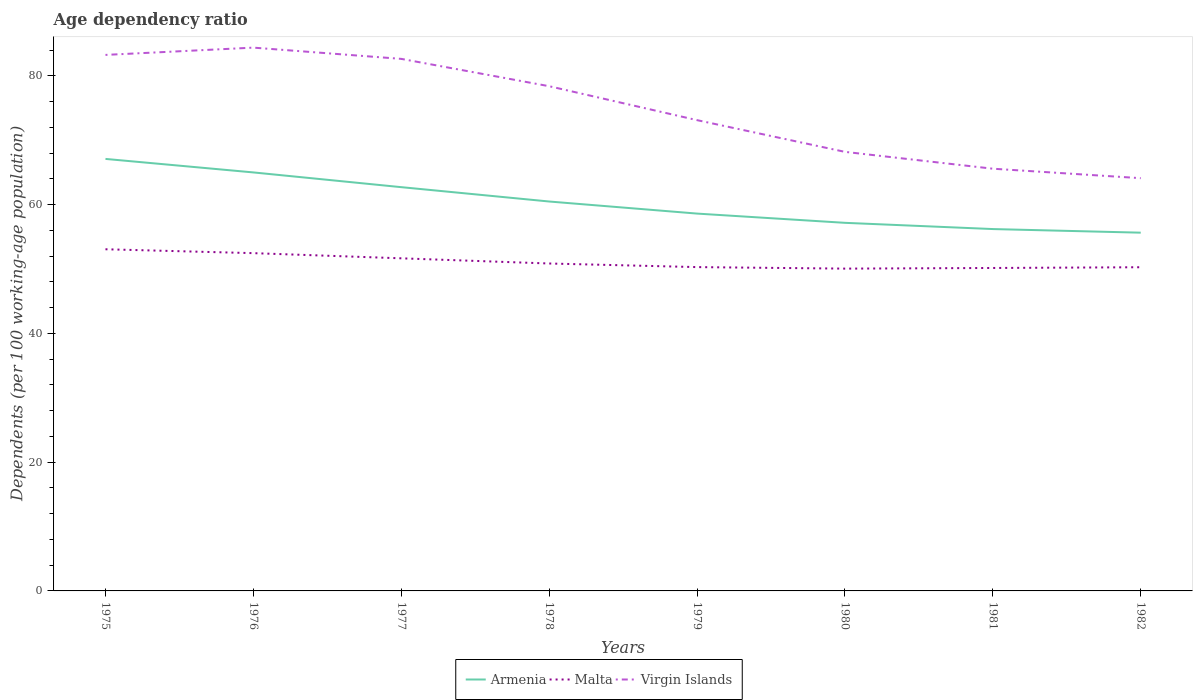How many different coloured lines are there?
Provide a succinct answer. 3. Across all years, what is the maximum age dependency ratio in in Armenia?
Make the answer very short. 55.64. What is the total age dependency ratio in in Malta in the graph?
Keep it short and to the point. 2.3. What is the difference between the highest and the second highest age dependency ratio in in Malta?
Ensure brevity in your answer.  3.01. How many lines are there?
Give a very brief answer. 3. How many years are there in the graph?
Provide a short and direct response. 8. What is the difference between two consecutive major ticks on the Y-axis?
Your answer should be very brief. 20. Does the graph contain any zero values?
Your answer should be very brief. No. Does the graph contain grids?
Give a very brief answer. No. What is the title of the graph?
Give a very brief answer. Age dependency ratio. What is the label or title of the X-axis?
Offer a very short reply. Years. What is the label or title of the Y-axis?
Offer a very short reply. Dependents (per 100 working-age population). What is the Dependents (per 100 working-age population) in Armenia in 1975?
Offer a terse response. 67.09. What is the Dependents (per 100 working-age population) of Malta in 1975?
Offer a terse response. 53.06. What is the Dependents (per 100 working-age population) of Virgin Islands in 1975?
Provide a short and direct response. 83.24. What is the Dependents (per 100 working-age population) of Armenia in 1976?
Ensure brevity in your answer.  64.99. What is the Dependents (per 100 working-age population) of Malta in 1976?
Your answer should be very brief. 52.46. What is the Dependents (per 100 working-age population) in Virgin Islands in 1976?
Provide a succinct answer. 84.37. What is the Dependents (per 100 working-age population) of Armenia in 1977?
Your answer should be very brief. 62.7. What is the Dependents (per 100 working-age population) in Malta in 1977?
Make the answer very short. 51.65. What is the Dependents (per 100 working-age population) of Virgin Islands in 1977?
Ensure brevity in your answer.  82.63. What is the Dependents (per 100 working-age population) in Armenia in 1978?
Your answer should be very brief. 60.48. What is the Dependents (per 100 working-age population) of Malta in 1978?
Your response must be concise. 50.85. What is the Dependents (per 100 working-age population) in Virgin Islands in 1978?
Your response must be concise. 78.38. What is the Dependents (per 100 working-age population) of Armenia in 1979?
Provide a short and direct response. 58.6. What is the Dependents (per 100 working-age population) in Malta in 1979?
Keep it short and to the point. 50.29. What is the Dependents (per 100 working-age population) of Virgin Islands in 1979?
Offer a very short reply. 73.11. What is the Dependents (per 100 working-age population) of Armenia in 1980?
Provide a short and direct response. 57.17. What is the Dependents (per 100 working-age population) of Malta in 1980?
Offer a very short reply. 50.05. What is the Dependents (per 100 working-age population) in Virgin Islands in 1980?
Your answer should be compact. 68.19. What is the Dependents (per 100 working-age population) of Armenia in 1981?
Offer a terse response. 56.2. What is the Dependents (per 100 working-age population) in Malta in 1981?
Keep it short and to the point. 50.15. What is the Dependents (per 100 working-age population) in Virgin Islands in 1981?
Your answer should be very brief. 65.57. What is the Dependents (per 100 working-age population) of Armenia in 1982?
Your response must be concise. 55.64. What is the Dependents (per 100 working-age population) of Malta in 1982?
Offer a very short reply. 50.27. What is the Dependents (per 100 working-age population) of Virgin Islands in 1982?
Offer a very short reply. 64.1. Across all years, what is the maximum Dependents (per 100 working-age population) of Armenia?
Offer a terse response. 67.09. Across all years, what is the maximum Dependents (per 100 working-age population) in Malta?
Keep it short and to the point. 53.06. Across all years, what is the maximum Dependents (per 100 working-age population) of Virgin Islands?
Your answer should be compact. 84.37. Across all years, what is the minimum Dependents (per 100 working-age population) of Armenia?
Ensure brevity in your answer.  55.64. Across all years, what is the minimum Dependents (per 100 working-age population) of Malta?
Make the answer very short. 50.05. Across all years, what is the minimum Dependents (per 100 working-age population) of Virgin Islands?
Your response must be concise. 64.1. What is the total Dependents (per 100 working-age population) in Armenia in the graph?
Provide a short and direct response. 482.87. What is the total Dependents (per 100 working-age population) in Malta in the graph?
Offer a very short reply. 408.78. What is the total Dependents (per 100 working-age population) of Virgin Islands in the graph?
Provide a short and direct response. 599.59. What is the difference between the Dependents (per 100 working-age population) in Armenia in 1975 and that in 1976?
Ensure brevity in your answer.  2.1. What is the difference between the Dependents (per 100 working-age population) in Malta in 1975 and that in 1976?
Give a very brief answer. 0.6. What is the difference between the Dependents (per 100 working-age population) in Virgin Islands in 1975 and that in 1976?
Keep it short and to the point. -1.13. What is the difference between the Dependents (per 100 working-age population) in Armenia in 1975 and that in 1977?
Keep it short and to the point. 4.39. What is the difference between the Dependents (per 100 working-age population) in Malta in 1975 and that in 1977?
Offer a terse response. 1.41. What is the difference between the Dependents (per 100 working-age population) in Virgin Islands in 1975 and that in 1977?
Ensure brevity in your answer.  0.62. What is the difference between the Dependents (per 100 working-age population) of Armenia in 1975 and that in 1978?
Make the answer very short. 6.62. What is the difference between the Dependents (per 100 working-age population) in Malta in 1975 and that in 1978?
Keep it short and to the point. 2.21. What is the difference between the Dependents (per 100 working-age population) in Virgin Islands in 1975 and that in 1978?
Ensure brevity in your answer.  4.86. What is the difference between the Dependents (per 100 working-age population) of Armenia in 1975 and that in 1979?
Make the answer very short. 8.49. What is the difference between the Dependents (per 100 working-age population) of Malta in 1975 and that in 1979?
Provide a short and direct response. 2.77. What is the difference between the Dependents (per 100 working-age population) of Virgin Islands in 1975 and that in 1979?
Provide a short and direct response. 10.13. What is the difference between the Dependents (per 100 working-age population) of Armenia in 1975 and that in 1980?
Offer a very short reply. 9.93. What is the difference between the Dependents (per 100 working-age population) of Malta in 1975 and that in 1980?
Keep it short and to the point. 3.01. What is the difference between the Dependents (per 100 working-age population) in Virgin Islands in 1975 and that in 1980?
Offer a terse response. 15.06. What is the difference between the Dependents (per 100 working-age population) of Armenia in 1975 and that in 1981?
Provide a short and direct response. 10.89. What is the difference between the Dependents (per 100 working-age population) of Malta in 1975 and that in 1981?
Provide a succinct answer. 2.91. What is the difference between the Dependents (per 100 working-age population) in Virgin Islands in 1975 and that in 1981?
Give a very brief answer. 17.67. What is the difference between the Dependents (per 100 working-age population) of Armenia in 1975 and that in 1982?
Make the answer very short. 11.46. What is the difference between the Dependents (per 100 working-age population) in Malta in 1975 and that in 1982?
Provide a short and direct response. 2.79. What is the difference between the Dependents (per 100 working-age population) in Virgin Islands in 1975 and that in 1982?
Make the answer very short. 19.14. What is the difference between the Dependents (per 100 working-age population) of Armenia in 1976 and that in 1977?
Provide a succinct answer. 2.29. What is the difference between the Dependents (per 100 working-age population) in Malta in 1976 and that in 1977?
Your response must be concise. 0.8. What is the difference between the Dependents (per 100 working-age population) in Virgin Islands in 1976 and that in 1977?
Make the answer very short. 1.75. What is the difference between the Dependents (per 100 working-age population) in Armenia in 1976 and that in 1978?
Provide a succinct answer. 4.52. What is the difference between the Dependents (per 100 working-age population) in Malta in 1976 and that in 1978?
Offer a terse response. 1.61. What is the difference between the Dependents (per 100 working-age population) in Virgin Islands in 1976 and that in 1978?
Give a very brief answer. 5.99. What is the difference between the Dependents (per 100 working-age population) of Armenia in 1976 and that in 1979?
Your response must be concise. 6.39. What is the difference between the Dependents (per 100 working-age population) of Malta in 1976 and that in 1979?
Keep it short and to the point. 2.17. What is the difference between the Dependents (per 100 working-age population) of Virgin Islands in 1976 and that in 1979?
Make the answer very short. 11.26. What is the difference between the Dependents (per 100 working-age population) in Armenia in 1976 and that in 1980?
Offer a terse response. 7.83. What is the difference between the Dependents (per 100 working-age population) in Malta in 1976 and that in 1980?
Your answer should be compact. 2.4. What is the difference between the Dependents (per 100 working-age population) in Virgin Islands in 1976 and that in 1980?
Provide a succinct answer. 16.19. What is the difference between the Dependents (per 100 working-age population) of Armenia in 1976 and that in 1981?
Provide a succinct answer. 8.8. What is the difference between the Dependents (per 100 working-age population) of Malta in 1976 and that in 1981?
Ensure brevity in your answer.  2.3. What is the difference between the Dependents (per 100 working-age population) of Virgin Islands in 1976 and that in 1981?
Provide a short and direct response. 18.8. What is the difference between the Dependents (per 100 working-age population) of Armenia in 1976 and that in 1982?
Your answer should be compact. 9.36. What is the difference between the Dependents (per 100 working-age population) of Malta in 1976 and that in 1982?
Ensure brevity in your answer.  2.19. What is the difference between the Dependents (per 100 working-age population) of Virgin Islands in 1976 and that in 1982?
Provide a short and direct response. 20.28. What is the difference between the Dependents (per 100 working-age population) in Armenia in 1977 and that in 1978?
Offer a terse response. 2.23. What is the difference between the Dependents (per 100 working-age population) in Malta in 1977 and that in 1978?
Your response must be concise. 0.81. What is the difference between the Dependents (per 100 working-age population) of Virgin Islands in 1977 and that in 1978?
Keep it short and to the point. 4.24. What is the difference between the Dependents (per 100 working-age population) of Armenia in 1977 and that in 1979?
Your response must be concise. 4.1. What is the difference between the Dependents (per 100 working-age population) of Malta in 1977 and that in 1979?
Make the answer very short. 1.36. What is the difference between the Dependents (per 100 working-age population) of Virgin Islands in 1977 and that in 1979?
Make the answer very short. 9.52. What is the difference between the Dependents (per 100 working-age population) of Armenia in 1977 and that in 1980?
Give a very brief answer. 5.54. What is the difference between the Dependents (per 100 working-age population) of Virgin Islands in 1977 and that in 1980?
Your answer should be compact. 14.44. What is the difference between the Dependents (per 100 working-age population) in Armenia in 1977 and that in 1981?
Offer a very short reply. 6.51. What is the difference between the Dependents (per 100 working-age population) of Malta in 1977 and that in 1981?
Offer a very short reply. 1.5. What is the difference between the Dependents (per 100 working-age population) in Virgin Islands in 1977 and that in 1981?
Your answer should be very brief. 17.06. What is the difference between the Dependents (per 100 working-age population) of Armenia in 1977 and that in 1982?
Your answer should be compact. 7.07. What is the difference between the Dependents (per 100 working-age population) of Malta in 1977 and that in 1982?
Your answer should be compact. 1.39. What is the difference between the Dependents (per 100 working-age population) of Virgin Islands in 1977 and that in 1982?
Ensure brevity in your answer.  18.53. What is the difference between the Dependents (per 100 working-age population) of Armenia in 1978 and that in 1979?
Offer a very short reply. 1.88. What is the difference between the Dependents (per 100 working-age population) of Malta in 1978 and that in 1979?
Make the answer very short. 0.56. What is the difference between the Dependents (per 100 working-age population) in Virgin Islands in 1978 and that in 1979?
Your answer should be compact. 5.27. What is the difference between the Dependents (per 100 working-age population) in Armenia in 1978 and that in 1980?
Keep it short and to the point. 3.31. What is the difference between the Dependents (per 100 working-age population) of Malta in 1978 and that in 1980?
Ensure brevity in your answer.  0.79. What is the difference between the Dependents (per 100 working-age population) in Virgin Islands in 1978 and that in 1980?
Your answer should be very brief. 10.2. What is the difference between the Dependents (per 100 working-age population) of Armenia in 1978 and that in 1981?
Offer a terse response. 4.28. What is the difference between the Dependents (per 100 working-age population) of Malta in 1978 and that in 1981?
Provide a short and direct response. 0.69. What is the difference between the Dependents (per 100 working-age population) of Virgin Islands in 1978 and that in 1981?
Ensure brevity in your answer.  12.81. What is the difference between the Dependents (per 100 working-age population) in Armenia in 1978 and that in 1982?
Offer a terse response. 4.84. What is the difference between the Dependents (per 100 working-age population) in Malta in 1978 and that in 1982?
Make the answer very short. 0.58. What is the difference between the Dependents (per 100 working-age population) of Virgin Islands in 1978 and that in 1982?
Give a very brief answer. 14.28. What is the difference between the Dependents (per 100 working-age population) of Armenia in 1979 and that in 1980?
Ensure brevity in your answer.  1.44. What is the difference between the Dependents (per 100 working-age population) in Malta in 1979 and that in 1980?
Offer a very short reply. 0.24. What is the difference between the Dependents (per 100 working-age population) in Virgin Islands in 1979 and that in 1980?
Provide a succinct answer. 4.92. What is the difference between the Dependents (per 100 working-age population) of Armenia in 1979 and that in 1981?
Provide a succinct answer. 2.4. What is the difference between the Dependents (per 100 working-age population) of Malta in 1979 and that in 1981?
Keep it short and to the point. 0.14. What is the difference between the Dependents (per 100 working-age population) of Virgin Islands in 1979 and that in 1981?
Make the answer very short. 7.54. What is the difference between the Dependents (per 100 working-age population) of Armenia in 1979 and that in 1982?
Your answer should be compact. 2.96. What is the difference between the Dependents (per 100 working-age population) of Malta in 1979 and that in 1982?
Offer a terse response. 0.02. What is the difference between the Dependents (per 100 working-age population) in Virgin Islands in 1979 and that in 1982?
Give a very brief answer. 9.01. What is the difference between the Dependents (per 100 working-age population) of Armenia in 1980 and that in 1981?
Provide a short and direct response. 0.97. What is the difference between the Dependents (per 100 working-age population) in Malta in 1980 and that in 1981?
Ensure brevity in your answer.  -0.1. What is the difference between the Dependents (per 100 working-age population) of Virgin Islands in 1980 and that in 1981?
Provide a succinct answer. 2.62. What is the difference between the Dependents (per 100 working-age population) in Armenia in 1980 and that in 1982?
Your answer should be compact. 1.53. What is the difference between the Dependents (per 100 working-age population) of Malta in 1980 and that in 1982?
Provide a succinct answer. -0.21. What is the difference between the Dependents (per 100 working-age population) of Virgin Islands in 1980 and that in 1982?
Your response must be concise. 4.09. What is the difference between the Dependents (per 100 working-age population) of Armenia in 1981 and that in 1982?
Your response must be concise. 0.56. What is the difference between the Dependents (per 100 working-age population) of Malta in 1981 and that in 1982?
Ensure brevity in your answer.  -0.11. What is the difference between the Dependents (per 100 working-age population) of Virgin Islands in 1981 and that in 1982?
Keep it short and to the point. 1.47. What is the difference between the Dependents (per 100 working-age population) in Armenia in 1975 and the Dependents (per 100 working-age population) in Malta in 1976?
Provide a succinct answer. 14.64. What is the difference between the Dependents (per 100 working-age population) in Armenia in 1975 and the Dependents (per 100 working-age population) in Virgin Islands in 1976?
Offer a terse response. -17.28. What is the difference between the Dependents (per 100 working-age population) of Malta in 1975 and the Dependents (per 100 working-age population) of Virgin Islands in 1976?
Your answer should be very brief. -31.31. What is the difference between the Dependents (per 100 working-age population) in Armenia in 1975 and the Dependents (per 100 working-age population) in Malta in 1977?
Offer a terse response. 15.44. What is the difference between the Dependents (per 100 working-age population) in Armenia in 1975 and the Dependents (per 100 working-age population) in Virgin Islands in 1977?
Provide a succinct answer. -15.54. What is the difference between the Dependents (per 100 working-age population) in Malta in 1975 and the Dependents (per 100 working-age population) in Virgin Islands in 1977?
Your answer should be compact. -29.57. What is the difference between the Dependents (per 100 working-age population) of Armenia in 1975 and the Dependents (per 100 working-age population) of Malta in 1978?
Offer a very short reply. 16.24. What is the difference between the Dependents (per 100 working-age population) of Armenia in 1975 and the Dependents (per 100 working-age population) of Virgin Islands in 1978?
Offer a very short reply. -11.29. What is the difference between the Dependents (per 100 working-age population) in Malta in 1975 and the Dependents (per 100 working-age population) in Virgin Islands in 1978?
Provide a short and direct response. -25.32. What is the difference between the Dependents (per 100 working-age population) of Armenia in 1975 and the Dependents (per 100 working-age population) of Malta in 1979?
Provide a succinct answer. 16.8. What is the difference between the Dependents (per 100 working-age population) in Armenia in 1975 and the Dependents (per 100 working-age population) in Virgin Islands in 1979?
Make the answer very short. -6.02. What is the difference between the Dependents (per 100 working-age population) in Malta in 1975 and the Dependents (per 100 working-age population) in Virgin Islands in 1979?
Give a very brief answer. -20.05. What is the difference between the Dependents (per 100 working-age population) of Armenia in 1975 and the Dependents (per 100 working-age population) of Malta in 1980?
Offer a very short reply. 17.04. What is the difference between the Dependents (per 100 working-age population) of Armenia in 1975 and the Dependents (per 100 working-age population) of Virgin Islands in 1980?
Provide a short and direct response. -1.1. What is the difference between the Dependents (per 100 working-age population) in Malta in 1975 and the Dependents (per 100 working-age population) in Virgin Islands in 1980?
Your answer should be compact. -15.13. What is the difference between the Dependents (per 100 working-age population) in Armenia in 1975 and the Dependents (per 100 working-age population) in Malta in 1981?
Your answer should be very brief. 16.94. What is the difference between the Dependents (per 100 working-age population) of Armenia in 1975 and the Dependents (per 100 working-age population) of Virgin Islands in 1981?
Provide a short and direct response. 1.52. What is the difference between the Dependents (per 100 working-age population) in Malta in 1975 and the Dependents (per 100 working-age population) in Virgin Islands in 1981?
Give a very brief answer. -12.51. What is the difference between the Dependents (per 100 working-age population) of Armenia in 1975 and the Dependents (per 100 working-age population) of Malta in 1982?
Provide a short and direct response. 16.82. What is the difference between the Dependents (per 100 working-age population) in Armenia in 1975 and the Dependents (per 100 working-age population) in Virgin Islands in 1982?
Your answer should be compact. 2.99. What is the difference between the Dependents (per 100 working-age population) in Malta in 1975 and the Dependents (per 100 working-age population) in Virgin Islands in 1982?
Provide a short and direct response. -11.04. What is the difference between the Dependents (per 100 working-age population) of Armenia in 1976 and the Dependents (per 100 working-age population) of Malta in 1977?
Keep it short and to the point. 13.34. What is the difference between the Dependents (per 100 working-age population) in Armenia in 1976 and the Dependents (per 100 working-age population) in Virgin Islands in 1977?
Provide a short and direct response. -17.63. What is the difference between the Dependents (per 100 working-age population) in Malta in 1976 and the Dependents (per 100 working-age population) in Virgin Islands in 1977?
Offer a terse response. -30.17. What is the difference between the Dependents (per 100 working-age population) in Armenia in 1976 and the Dependents (per 100 working-age population) in Malta in 1978?
Offer a terse response. 14.14. What is the difference between the Dependents (per 100 working-age population) in Armenia in 1976 and the Dependents (per 100 working-age population) in Virgin Islands in 1978?
Make the answer very short. -13.39. What is the difference between the Dependents (per 100 working-age population) in Malta in 1976 and the Dependents (per 100 working-age population) in Virgin Islands in 1978?
Make the answer very short. -25.93. What is the difference between the Dependents (per 100 working-age population) in Armenia in 1976 and the Dependents (per 100 working-age population) in Malta in 1979?
Keep it short and to the point. 14.7. What is the difference between the Dependents (per 100 working-age population) in Armenia in 1976 and the Dependents (per 100 working-age population) in Virgin Islands in 1979?
Provide a short and direct response. -8.12. What is the difference between the Dependents (per 100 working-age population) in Malta in 1976 and the Dependents (per 100 working-age population) in Virgin Islands in 1979?
Your response must be concise. -20.66. What is the difference between the Dependents (per 100 working-age population) of Armenia in 1976 and the Dependents (per 100 working-age population) of Malta in 1980?
Ensure brevity in your answer.  14.94. What is the difference between the Dependents (per 100 working-age population) in Armenia in 1976 and the Dependents (per 100 working-age population) in Virgin Islands in 1980?
Make the answer very short. -3.19. What is the difference between the Dependents (per 100 working-age population) of Malta in 1976 and the Dependents (per 100 working-age population) of Virgin Islands in 1980?
Provide a succinct answer. -15.73. What is the difference between the Dependents (per 100 working-age population) of Armenia in 1976 and the Dependents (per 100 working-age population) of Malta in 1981?
Keep it short and to the point. 14.84. What is the difference between the Dependents (per 100 working-age population) of Armenia in 1976 and the Dependents (per 100 working-age population) of Virgin Islands in 1981?
Ensure brevity in your answer.  -0.58. What is the difference between the Dependents (per 100 working-age population) of Malta in 1976 and the Dependents (per 100 working-age population) of Virgin Islands in 1981?
Provide a short and direct response. -13.11. What is the difference between the Dependents (per 100 working-age population) of Armenia in 1976 and the Dependents (per 100 working-age population) of Malta in 1982?
Your answer should be compact. 14.72. What is the difference between the Dependents (per 100 working-age population) in Armenia in 1976 and the Dependents (per 100 working-age population) in Virgin Islands in 1982?
Provide a succinct answer. 0.89. What is the difference between the Dependents (per 100 working-age population) in Malta in 1976 and the Dependents (per 100 working-age population) in Virgin Islands in 1982?
Offer a terse response. -11.64. What is the difference between the Dependents (per 100 working-age population) in Armenia in 1977 and the Dependents (per 100 working-age population) in Malta in 1978?
Your answer should be compact. 11.86. What is the difference between the Dependents (per 100 working-age population) of Armenia in 1977 and the Dependents (per 100 working-age population) of Virgin Islands in 1978?
Give a very brief answer. -15.68. What is the difference between the Dependents (per 100 working-age population) of Malta in 1977 and the Dependents (per 100 working-age population) of Virgin Islands in 1978?
Your answer should be very brief. -26.73. What is the difference between the Dependents (per 100 working-age population) of Armenia in 1977 and the Dependents (per 100 working-age population) of Malta in 1979?
Keep it short and to the point. 12.42. What is the difference between the Dependents (per 100 working-age population) in Armenia in 1977 and the Dependents (per 100 working-age population) in Virgin Islands in 1979?
Offer a very short reply. -10.41. What is the difference between the Dependents (per 100 working-age population) of Malta in 1977 and the Dependents (per 100 working-age population) of Virgin Islands in 1979?
Give a very brief answer. -21.46. What is the difference between the Dependents (per 100 working-age population) in Armenia in 1977 and the Dependents (per 100 working-age population) in Malta in 1980?
Offer a terse response. 12.65. What is the difference between the Dependents (per 100 working-age population) of Armenia in 1977 and the Dependents (per 100 working-age population) of Virgin Islands in 1980?
Provide a succinct answer. -5.48. What is the difference between the Dependents (per 100 working-age population) in Malta in 1977 and the Dependents (per 100 working-age population) in Virgin Islands in 1980?
Provide a succinct answer. -16.53. What is the difference between the Dependents (per 100 working-age population) of Armenia in 1977 and the Dependents (per 100 working-age population) of Malta in 1981?
Ensure brevity in your answer.  12.55. What is the difference between the Dependents (per 100 working-age population) of Armenia in 1977 and the Dependents (per 100 working-age population) of Virgin Islands in 1981?
Give a very brief answer. -2.87. What is the difference between the Dependents (per 100 working-age population) in Malta in 1977 and the Dependents (per 100 working-age population) in Virgin Islands in 1981?
Offer a very short reply. -13.92. What is the difference between the Dependents (per 100 working-age population) in Armenia in 1977 and the Dependents (per 100 working-age population) in Malta in 1982?
Keep it short and to the point. 12.44. What is the difference between the Dependents (per 100 working-age population) in Armenia in 1977 and the Dependents (per 100 working-age population) in Virgin Islands in 1982?
Give a very brief answer. -1.39. What is the difference between the Dependents (per 100 working-age population) in Malta in 1977 and the Dependents (per 100 working-age population) in Virgin Islands in 1982?
Provide a short and direct response. -12.45. What is the difference between the Dependents (per 100 working-age population) in Armenia in 1978 and the Dependents (per 100 working-age population) in Malta in 1979?
Provide a short and direct response. 10.19. What is the difference between the Dependents (per 100 working-age population) in Armenia in 1978 and the Dependents (per 100 working-age population) in Virgin Islands in 1979?
Provide a short and direct response. -12.64. What is the difference between the Dependents (per 100 working-age population) of Malta in 1978 and the Dependents (per 100 working-age population) of Virgin Islands in 1979?
Your response must be concise. -22.26. What is the difference between the Dependents (per 100 working-age population) in Armenia in 1978 and the Dependents (per 100 working-age population) in Malta in 1980?
Your answer should be compact. 10.42. What is the difference between the Dependents (per 100 working-age population) in Armenia in 1978 and the Dependents (per 100 working-age population) in Virgin Islands in 1980?
Your response must be concise. -7.71. What is the difference between the Dependents (per 100 working-age population) in Malta in 1978 and the Dependents (per 100 working-age population) in Virgin Islands in 1980?
Offer a terse response. -17.34. What is the difference between the Dependents (per 100 working-age population) in Armenia in 1978 and the Dependents (per 100 working-age population) in Malta in 1981?
Offer a terse response. 10.32. What is the difference between the Dependents (per 100 working-age population) of Armenia in 1978 and the Dependents (per 100 working-age population) of Virgin Islands in 1981?
Make the answer very short. -5.09. What is the difference between the Dependents (per 100 working-age population) of Malta in 1978 and the Dependents (per 100 working-age population) of Virgin Islands in 1981?
Your answer should be very brief. -14.72. What is the difference between the Dependents (per 100 working-age population) of Armenia in 1978 and the Dependents (per 100 working-age population) of Malta in 1982?
Keep it short and to the point. 10.21. What is the difference between the Dependents (per 100 working-age population) of Armenia in 1978 and the Dependents (per 100 working-age population) of Virgin Islands in 1982?
Offer a terse response. -3.62. What is the difference between the Dependents (per 100 working-age population) of Malta in 1978 and the Dependents (per 100 working-age population) of Virgin Islands in 1982?
Give a very brief answer. -13.25. What is the difference between the Dependents (per 100 working-age population) in Armenia in 1979 and the Dependents (per 100 working-age population) in Malta in 1980?
Your response must be concise. 8.55. What is the difference between the Dependents (per 100 working-age population) of Armenia in 1979 and the Dependents (per 100 working-age population) of Virgin Islands in 1980?
Give a very brief answer. -9.59. What is the difference between the Dependents (per 100 working-age population) in Malta in 1979 and the Dependents (per 100 working-age population) in Virgin Islands in 1980?
Ensure brevity in your answer.  -17.9. What is the difference between the Dependents (per 100 working-age population) of Armenia in 1979 and the Dependents (per 100 working-age population) of Malta in 1981?
Offer a very short reply. 8.45. What is the difference between the Dependents (per 100 working-age population) of Armenia in 1979 and the Dependents (per 100 working-age population) of Virgin Islands in 1981?
Keep it short and to the point. -6.97. What is the difference between the Dependents (per 100 working-age population) of Malta in 1979 and the Dependents (per 100 working-age population) of Virgin Islands in 1981?
Your answer should be compact. -15.28. What is the difference between the Dependents (per 100 working-age population) in Armenia in 1979 and the Dependents (per 100 working-age population) in Malta in 1982?
Keep it short and to the point. 8.33. What is the difference between the Dependents (per 100 working-age population) in Armenia in 1979 and the Dependents (per 100 working-age population) in Virgin Islands in 1982?
Provide a succinct answer. -5.5. What is the difference between the Dependents (per 100 working-age population) of Malta in 1979 and the Dependents (per 100 working-age population) of Virgin Islands in 1982?
Offer a very short reply. -13.81. What is the difference between the Dependents (per 100 working-age population) in Armenia in 1980 and the Dependents (per 100 working-age population) in Malta in 1981?
Give a very brief answer. 7.01. What is the difference between the Dependents (per 100 working-age population) in Armenia in 1980 and the Dependents (per 100 working-age population) in Virgin Islands in 1981?
Your answer should be compact. -8.4. What is the difference between the Dependents (per 100 working-age population) in Malta in 1980 and the Dependents (per 100 working-age population) in Virgin Islands in 1981?
Provide a short and direct response. -15.52. What is the difference between the Dependents (per 100 working-age population) in Armenia in 1980 and the Dependents (per 100 working-age population) in Malta in 1982?
Offer a very short reply. 6.9. What is the difference between the Dependents (per 100 working-age population) in Armenia in 1980 and the Dependents (per 100 working-age population) in Virgin Islands in 1982?
Offer a very short reply. -6.93. What is the difference between the Dependents (per 100 working-age population) of Malta in 1980 and the Dependents (per 100 working-age population) of Virgin Islands in 1982?
Provide a short and direct response. -14.05. What is the difference between the Dependents (per 100 working-age population) of Armenia in 1981 and the Dependents (per 100 working-age population) of Malta in 1982?
Ensure brevity in your answer.  5.93. What is the difference between the Dependents (per 100 working-age population) in Armenia in 1981 and the Dependents (per 100 working-age population) in Virgin Islands in 1982?
Your answer should be very brief. -7.9. What is the difference between the Dependents (per 100 working-age population) in Malta in 1981 and the Dependents (per 100 working-age population) in Virgin Islands in 1982?
Provide a short and direct response. -13.95. What is the average Dependents (per 100 working-age population) of Armenia per year?
Keep it short and to the point. 60.36. What is the average Dependents (per 100 working-age population) in Malta per year?
Offer a terse response. 51.1. What is the average Dependents (per 100 working-age population) of Virgin Islands per year?
Provide a short and direct response. 74.95. In the year 1975, what is the difference between the Dependents (per 100 working-age population) of Armenia and Dependents (per 100 working-age population) of Malta?
Provide a succinct answer. 14.03. In the year 1975, what is the difference between the Dependents (per 100 working-age population) in Armenia and Dependents (per 100 working-age population) in Virgin Islands?
Provide a succinct answer. -16.15. In the year 1975, what is the difference between the Dependents (per 100 working-age population) of Malta and Dependents (per 100 working-age population) of Virgin Islands?
Offer a very short reply. -30.18. In the year 1976, what is the difference between the Dependents (per 100 working-age population) of Armenia and Dependents (per 100 working-age population) of Malta?
Your response must be concise. 12.54. In the year 1976, what is the difference between the Dependents (per 100 working-age population) of Armenia and Dependents (per 100 working-age population) of Virgin Islands?
Offer a very short reply. -19.38. In the year 1976, what is the difference between the Dependents (per 100 working-age population) in Malta and Dependents (per 100 working-age population) in Virgin Islands?
Your response must be concise. -31.92. In the year 1977, what is the difference between the Dependents (per 100 working-age population) in Armenia and Dependents (per 100 working-age population) in Malta?
Provide a succinct answer. 11.05. In the year 1977, what is the difference between the Dependents (per 100 working-age population) in Armenia and Dependents (per 100 working-age population) in Virgin Islands?
Your response must be concise. -19.92. In the year 1977, what is the difference between the Dependents (per 100 working-age population) in Malta and Dependents (per 100 working-age population) in Virgin Islands?
Make the answer very short. -30.97. In the year 1978, what is the difference between the Dependents (per 100 working-age population) in Armenia and Dependents (per 100 working-age population) in Malta?
Your response must be concise. 9.63. In the year 1978, what is the difference between the Dependents (per 100 working-age population) in Armenia and Dependents (per 100 working-age population) in Virgin Islands?
Offer a terse response. -17.91. In the year 1978, what is the difference between the Dependents (per 100 working-age population) in Malta and Dependents (per 100 working-age population) in Virgin Islands?
Offer a very short reply. -27.53. In the year 1979, what is the difference between the Dependents (per 100 working-age population) in Armenia and Dependents (per 100 working-age population) in Malta?
Keep it short and to the point. 8.31. In the year 1979, what is the difference between the Dependents (per 100 working-age population) in Armenia and Dependents (per 100 working-age population) in Virgin Islands?
Provide a succinct answer. -14.51. In the year 1979, what is the difference between the Dependents (per 100 working-age population) in Malta and Dependents (per 100 working-age population) in Virgin Islands?
Offer a terse response. -22.82. In the year 1980, what is the difference between the Dependents (per 100 working-age population) in Armenia and Dependents (per 100 working-age population) in Malta?
Your response must be concise. 7.11. In the year 1980, what is the difference between the Dependents (per 100 working-age population) in Armenia and Dependents (per 100 working-age population) in Virgin Islands?
Make the answer very short. -11.02. In the year 1980, what is the difference between the Dependents (per 100 working-age population) of Malta and Dependents (per 100 working-age population) of Virgin Islands?
Your response must be concise. -18.13. In the year 1981, what is the difference between the Dependents (per 100 working-age population) of Armenia and Dependents (per 100 working-age population) of Malta?
Your answer should be compact. 6.04. In the year 1981, what is the difference between the Dependents (per 100 working-age population) in Armenia and Dependents (per 100 working-age population) in Virgin Islands?
Your answer should be very brief. -9.37. In the year 1981, what is the difference between the Dependents (per 100 working-age population) of Malta and Dependents (per 100 working-age population) of Virgin Islands?
Make the answer very short. -15.42. In the year 1982, what is the difference between the Dependents (per 100 working-age population) of Armenia and Dependents (per 100 working-age population) of Malta?
Make the answer very short. 5.37. In the year 1982, what is the difference between the Dependents (per 100 working-age population) in Armenia and Dependents (per 100 working-age population) in Virgin Islands?
Make the answer very short. -8.46. In the year 1982, what is the difference between the Dependents (per 100 working-age population) in Malta and Dependents (per 100 working-age population) in Virgin Islands?
Ensure brevity in your answer.  -13.83. What is the ratio of the Dependents (per 100 working-age population) in Armenia in 1975 to that in 1976?
Provide a short and direct response. 1.03. What is the ratio of the Dependents (per 100 working-age population) of Malta in 1975 to that in 1976?
Make the answer very short. 1.01. What is the ratio of the Dependents (per 100 working-age population) of Virgin Islands in 1975 to that in 1976?
Make the answer very short. 0.99. What is the ratio of the Dependents (per 100 working-age population) in Armenia in 1975 to that in 1977?
Offer a very short reply. 1.07. What is the ratio of the Dependents (per 100 working-age population) in Malta in 1975 to that in 1977?
Your answer should be compact. 1.03. What is the ratio of the Dependents (per 100 working-age population) of Virgin Islands in 1975 to that in 1977?
Your answer should be very brief. 1.01. What is the ratio of the Dependents (per 100 working-age population) in Armenia in 1975 to that in 1978?
Your response must be concise. 1.11. What is the ratio of the Dependents (per 100 working-age population) of Malta in 1975 to that in 1978?
Make the answer very short. 1.04. What is the ratio of the Dependents (per 100 working-age population) of Virgin Islands in 1975 to that in 1978?
Offer a terse response. 1.06. What is the ratio of the Dependents (per 100 working-age population) in Armenia in 1975 to that in 1979?
Your answer should be compact. 1.14. What is the ratio of the Dependents (per 100 working-age population) of Malta in 1975 to that in 1979?
Offer a terse response. 1.06. What is the ratio of the Dependents (per 100 working-age population) in Virgin Islands in 1975 to that in 1979?
Offer a terse response. 1.14. What is the ratio of the Dependents (per 100 working-age population) of Armenia in 1975 to that in 1980?
Keep it short and to the point. 1.17. What is the ratio of the Dependents (per 100 working-age population) of Malta in 1975 to that in 1980?
Offer a very short reply. 1.06. What is the ratio of the Dependents (per 100 working-age population) in Virgin Islands in 1975 to that in 1980?
Keep it short and to the point. 1.22. What is the ratio of the Dependents (per 100 working-age population) of Armenia in 1975 to that in 1981?
Offer a terse response. 1.19. What is the ratio of the Dependents (per 100 working-age population) in Malta in 1975 to that in 1981?
Offer a terse response. 1.06. What is the ratio of the Dependents (per 100 working-age population) in Virgin Islands in 1975 to that in 1981?
Provide a succinct answer. 1.27. What is the ratio of the Dependents (per 100 working-age population) of Armenia in 1975 to that in 1982?
Provide a short and direct response. 1.21. What is the ratio of the Dependents (per 100 working-age population) in Malta in 1975 to that in 1982?
Your answer should be compact. 1.06. What is the ratio of the Dependents (per 100 working-age population) in Virgin Islands in 1975 to that in 1982?
Your response must be concise. 1.3. What is the ratio of the Dependents (per 100 working-age population) of Armenia in 1976 to that in 1977?
Ensure brevity in your answer.  1.04. What is the ratio of the Dependents (per 100 working-age population) of Malta in 1976 to that in 1977?
Your answer should be compact. 1.02. What is the ratio of the Dependents (per 100 working-age population) in Virgin Islands in 1976 to that in 1977?
Your response must be concise. 1.02. What is the ratio of the Dependents (per 100 working-age population) in Armenia in 1976 to that in 1978?
Provide a short and direct response. 1.07. What is the ratio of the Dependents (per 100 working-age population) in Malta in 1976 to that in 1978?
Offer a very short reply. 1.03. What is the ratio of the Dependents (per 100 working-age population) of Virgin Islands in 1976 to that in 1978?
Your answer should be very brief. 1.08. What is the ratio of the Dependents (per 100 working-age population) of Armenia in 1976 to that in 1979?
Offer a terse response. 1.11. What is the ratio of the Dependents (per 100 working-age population) in Malta in 1976 to that in 1979?
Your answer should be compact. 1.04. What is the ratio of the Dependents (per 100 working-age population) in Virgin Islands in 1976 to that in 1979?
Your answer should be very brief. 1.15. What is the ratio of the Dependents (per 100 working-age population) in Armenia in 1976 to that in 1980?
Offer a terse response. 1.14. What is the ratio of the Dependents (per 100 working-age population) in Malta in 1976 to that in 1980?
Keep it short and to the point. 1.05. What is the ratio of the Dependents (per 100 working-age population) of Virgin Islands in 1976 to that in 1980?
Keep it short and to the point. 1.24. What is the ratio of the Dependents (per 100 working-age population) of Armenia in 1976 to that in 1981?
Your answer should be compact. 1.16. What is the ratio of the Dependents (per 100 working-age population) in Malta in 1976 to that in 1981?
Your answer should be compact. 1.05. What is the ratio of the Dependents (per 100 working-age population) in Virgin Islands in 1976 to that in 1981?
Keep it short and to the point. 1.29. What is the ratio of the Dependents (per 100 working-age population) of Armenia in 1976 to that in 1982?
Your answer should be compact. 1.17. What is the ratio of the Dependents (per 100 working-age population) of Malta in 1976 to that in 1982?
Give a very brief answer. 1.04. What is the ratio of the Dependents (per 100 working-age population) in Virgin Islands in 1976 to that in 1982?
Your answer should be compact. 1.32. What is the ratio of the Dependents (per 100 working-age population) of Armenia in 1977 to that in 1978?
Provide a succinct answer. 1.04. What is the ratio of the Dependents (per 100 working-age population) of Malta in 1977 to that in 1978?
Your answer should be very brief. 1.02. What is the ratio of the Dependents (per 100 working-age population) of Virgin Islands in 1977 to that in 1978?
Your answer should be very brief. 1.05. What is the ratio of the Dependents (per 100 working-age population) of Armenia in 1977 to that in 1979?
Offer a very short reply. 1.07. What is the ratio of the Dependents (per 100 working-age population) of Malta in 1977 to that in 1979?
Provide a succinct answer. 1.03. What is the ratio of the Dependents (per 100 working-age population) in Virgin Islands in 1977 to that in 1979?
Offer a terse response. 1.13. What is the ratio of the Dependents (per 100 working-age population) in Armenia in 1977 to that in 1980?
Provide a succinct answer. 1.1. What is the ratio of the Dependents (per 100 working-age population) in Malta in 1977 to that in 1980?
Your answer should be compact. 1.03. What is the ratio of the Dependents (per 100 working-age population) in Virgin Islands in 1977 to that in 1980?
Give a very brief answer. 1.21. What is the ratio of the Dependents (per 100 working-age population) of Armenia in 1977 to that in 1981?
Provide a succinct answer. 1.12. What is the ratio of the Dependents (per 100 working-age population) in Malta in 1977 to that in 1981?
Offer a terse response. 1.03. What is the ratio of the Dependents (per 100 working-age population) in Virgin Islands in 1977 to that in 1981?
Provide a short and direct response. 1.26. What is the ratio of the Dependents (per 100 working-age population) of Armenia in 1977 to that in 1982?
Offer a terse response. 1.13. What is the ratio of the Dependents (per 100 working-age population) of Malta in 1977 to that in 1982?
Your response must be concise. 1.03. What is the ratio of the Dependents (per 100 working-age population) of Virgin Islands in 1977 to that in 1982?
Make the answer very short. 1.29. What is the ratio of the Dependents (per 100 working-age population) in Armenia in 1978 to that in 1979?
Ensure brevity in your answer.  1.03. What is the ratio of the Dependents (per 100 working-age population) of Malta in 1978 to that in 1979?
Your response must be concise. 1.01. What is the ratio of the Dependents (per 100 working-age population) in Virgin Islands in 1978 to that in 1979?
Give a very brief answer. 1.07. What is the ratio of the Dependents (per 100 working-age population) of Armenia in 1978 to that in 1980?
Keep it short and to the point. 1.06. What is the ratio of the Dependents (per 100 working-age population) in Malta in 1978 to that in 1980?
Your answer should be compact. 1.02. What is the ratio of the Dependents (per 100 working-age population) in Virgin Islands in 1978 to that in 1980?
Provide a succinct answer. 1.15. What is the ratio of the Dependents (per 100 working-age population) of Armenia in 1978 to that in 1981?
Give a very brief answer. 1.08. What is the ratio of the Dependents (per 100 working-age population) of Malta in 1978 to that in 1981?
Ensure brevity in your answer.  1.01. What is the ratio of the Dependents (per 100 working-age population) in Virgin Islands in 1978 to that in 1981?
Offer a very short reply. 1.2. What is the ratio of the Dependents (per 100 working-age population) of Armenia in 1978 to that in 1982?
Make the answer very short. 1.09. What is the ratio of the Dependents (per 100 working-age population) in Malta in 1978 to that in 1982?
Ensure brevity in your answer.  1.01. What is the ratio of the Dependents (per 100 working-age population) of Virgin Islands in 1978 to that in 1982?
Ensure brevity in your answer.  1.22. What is the ratio of the Dependents (per 100 working-age population) in Armenia in 1979 to that in 1980?
Offer a terse response. 1.03. What is the ratio of the Dependents (per 100 working-age population) in Virgin Islands in 1979 to that in 1980?
Make the answer very short. 1.07. What is the ratio of the Dependents (per 100 working-age population) in Armenia in 1979 to that in 1981?
Ensure brevity in your answer.  1.04. What is the ratio of the Dependents (per 100 working-age population) of Virgin Islands in 1979 to that in 1981?
Keep it short and to the point. 1.11. What is the ratio of the Dependents (per 100 working-age population) in Armenia in 1979 to that in 1982?
Your answer should be compact. 1.05. What is the ratio of the Dependents (per 100 working-age population) in Virgin Islands in 1979 to that in 1982?
Your answer should be compact. 1.14. What is the ratio of the Dependents (per 100 working-age population) of Armenia in 1980 to that in 1981?
Ensure brevity in your answer.  1.02. What is the ratio of the Dependents (per 100 working-age population) in Malta in 1980 to that in 1981?
Make the answer very short. 1. What is the ratio of the Dependents (per 100 working-age population) in Virgin Islands in 1980 to that in 1981?
Make the answer very short. 1.04. What is the ratio of the Dependents (per 100 working-age population) in Armenia in 1980 to that in 1982?
Provide a short and direct response. 1.03. What is the ratio of the Dependents (per 100 working-age population) of Virgin Islands in 1980 to that in 1982?
Offer a terse response. 1.06. What is the ratio of the Dependents (per 100 working-age population) in Armenia in 1981 to that in 1982?
Provide a short and direct response. 1.01. What is the ratio of the Dependents (per 100 working-age population) in Virgin Islands in 1981 to that in 1982?
Give a very brief answer. 1.02. What is the difference between the highest and the second highest Dependents (per 100 working-age population) of Armenia?
Provide a short and direct response. 2.1. What is the difference between the highest and the second highest Dependents (per 100 working-age population) of Malta?
Provide a succinct answer. 0.6. What is the difference between the highest and the second highest Dependents (per 100 working-age population) in Virgin Islands?
Make the answer very short. 1.13. What is the difference between the highest and the lowest Dependents (per 100 working-age population) in Armenia?
Give a very brief answer. 11.46. What is the difference between the highest and the lowest Dependents (per 100 working-age population) in Malta?
Your answer should be very brief. 3.01. What is the difference between the highest and the lowest Dependents (per 100 working-age population) in Virgin Islands?
Your answer should be very brief. 20.28. 